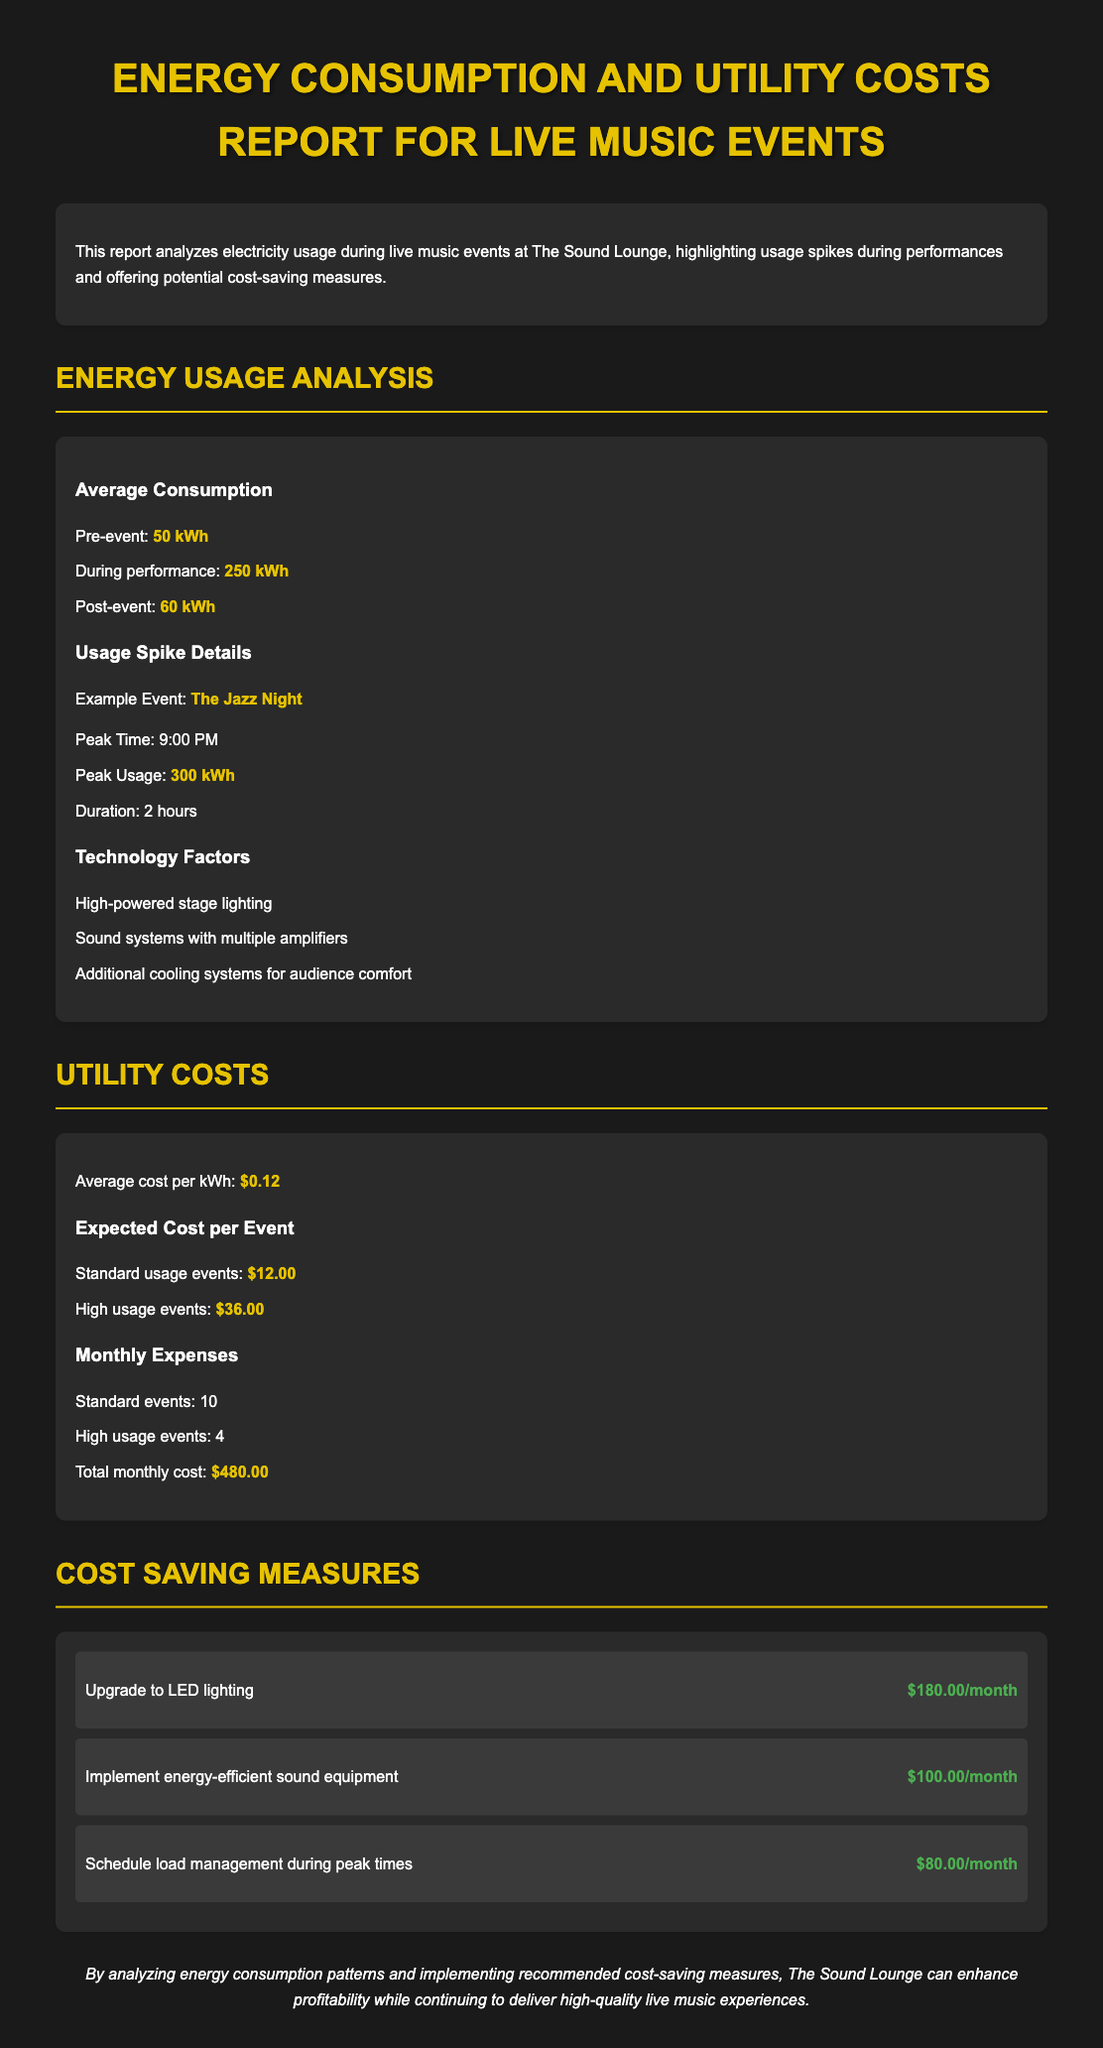What is the average electricity consumption during performances? The average electricity consumption during performances is stated in the document, which is 250 kWh.
Answer: 250 kWh What was the peak usage during The Jazz Night? The document specifies that the peak usage during The Jazz Night was 300 kWh.
Answer: 300 kWh What is the average cost per kilowatt-hour? The average cost per kilowatt-hour is mentioned in the report, which is $0.12.
Answer: $0.12 How many high usage events occur monthly on average? The document lists that there are 4 high usage events per month.
Answer: 4 What is a potential cost-saving measure mentioned in the report? The report outlines several cost-saving measures; one example is upgrading to LED lighting.
Answer: Upgrade to LED lighting How much can be saved per month by implementing load management? The document states that implementing load management during peak times could save $80.00 per month.
Answer: $80.00 What is the total monthly cost of electricity for The Sound Lounge? The total monthly cost is calculated in the report, which amounts to $480.00.
Answer: $480.00 What is one factor influencing high energy usage listed in the document? The report points out high-powered stage lighting as one factor influencing high energy usage.
Answer: High-powered stage lighting What was the average pre-event usage recorded? The document notes that the average pre-event usage is 50 kWh.
Answer: 50 kWh 